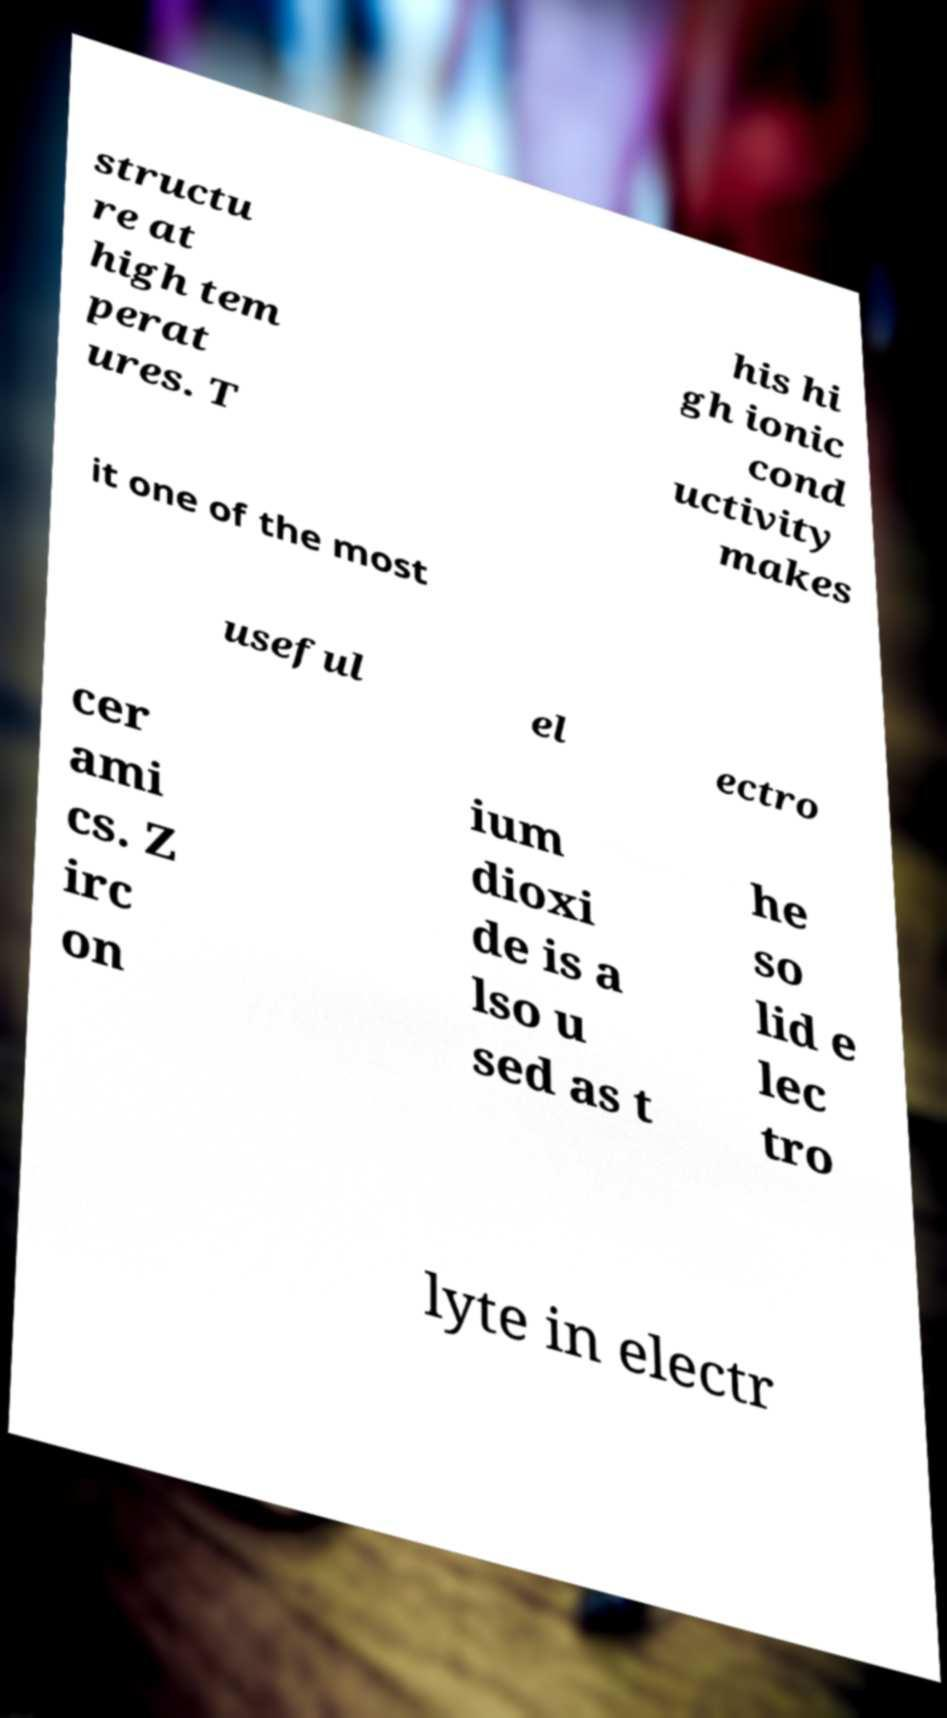Could you extract and type out the text from this image? structu re at high tem perat ures. T his hi gh ionic cond uctivity makes it one of the most useful el ectro cer ami cs. Z irc on ium dioxi de is a lso u sed as t he so lid e lec tro lyte in electr 